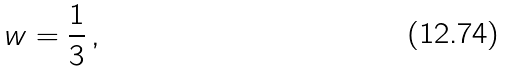Convert formula to latex. <formula><loc_0><loc_0><loc_500><loc_500>w = \frac { 1 } { 3 } \, ,</formula> 